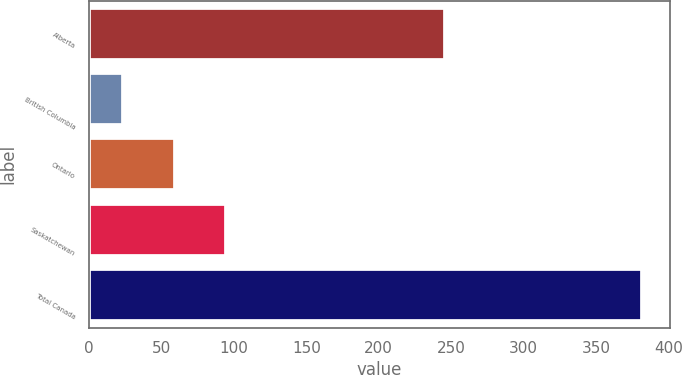<chart> <loc_0><loc_0><loc_500><loc_500><bar_chart><fcel>Alberta<fcel>British Columbia<fcel>Ontario<fcel>Saskatchewan<fcel>Total Canada<nl><fcel>246<fcel>23<fcel>58.9<fcel>94.8<fcel>382<nl></chart> 